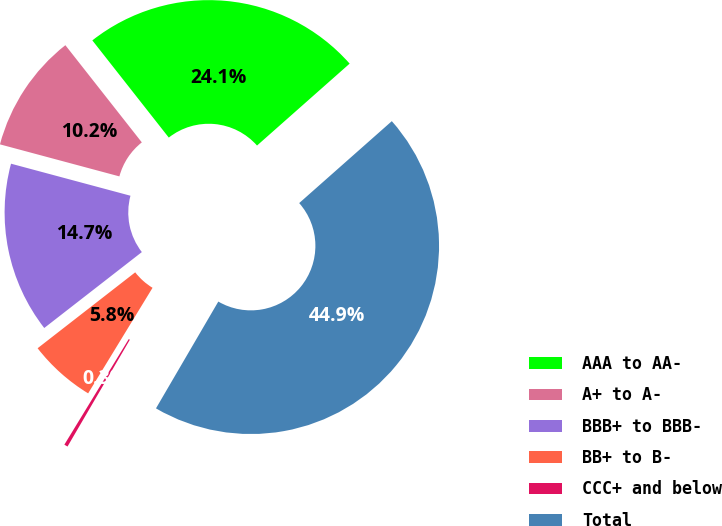Convert chart to OTSL. <chart><loc_0><loc_0><loc_500><loc_500><pie_chart><fcel>AAA to AA-<fcel>A+ to A-<fcel>BBB+ to BBB-<fcel>BB+ to B-<fcel>CCC+ and below<fcel>Total<nl><fcel>24.08%<fcel>10.22%<fcel>14.69%<fcel>5.76%<fcel>0.31%<fcel>44.93%<nl></chart> 